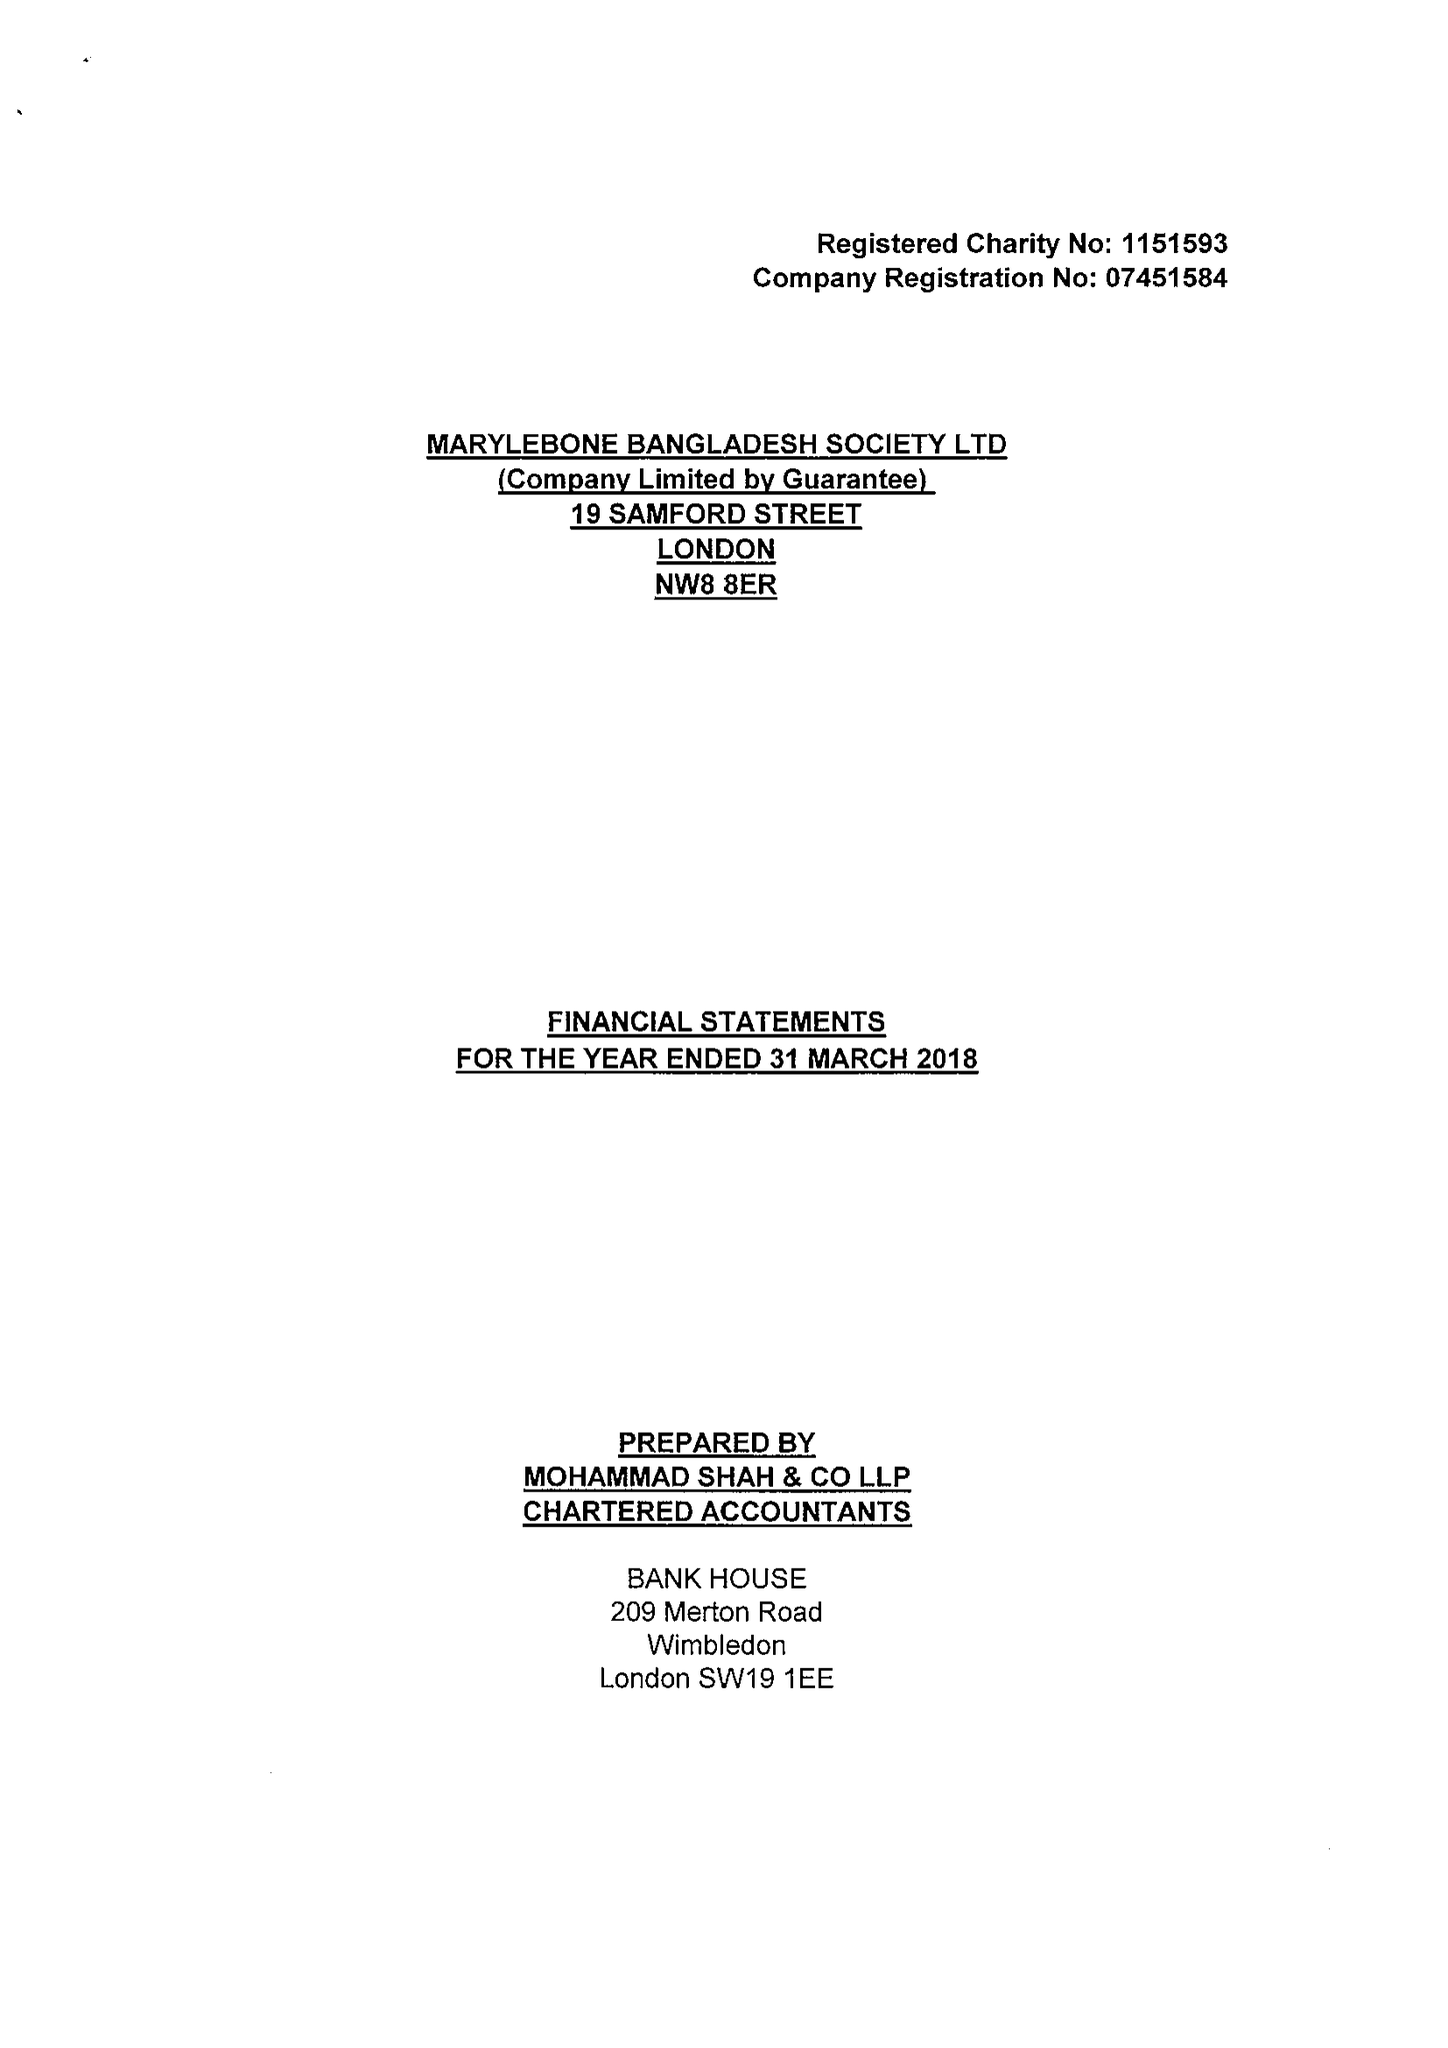What is the value for the spending_annually_in_british_pounds?
Answer the question using a single word or phrase. 139936.00 